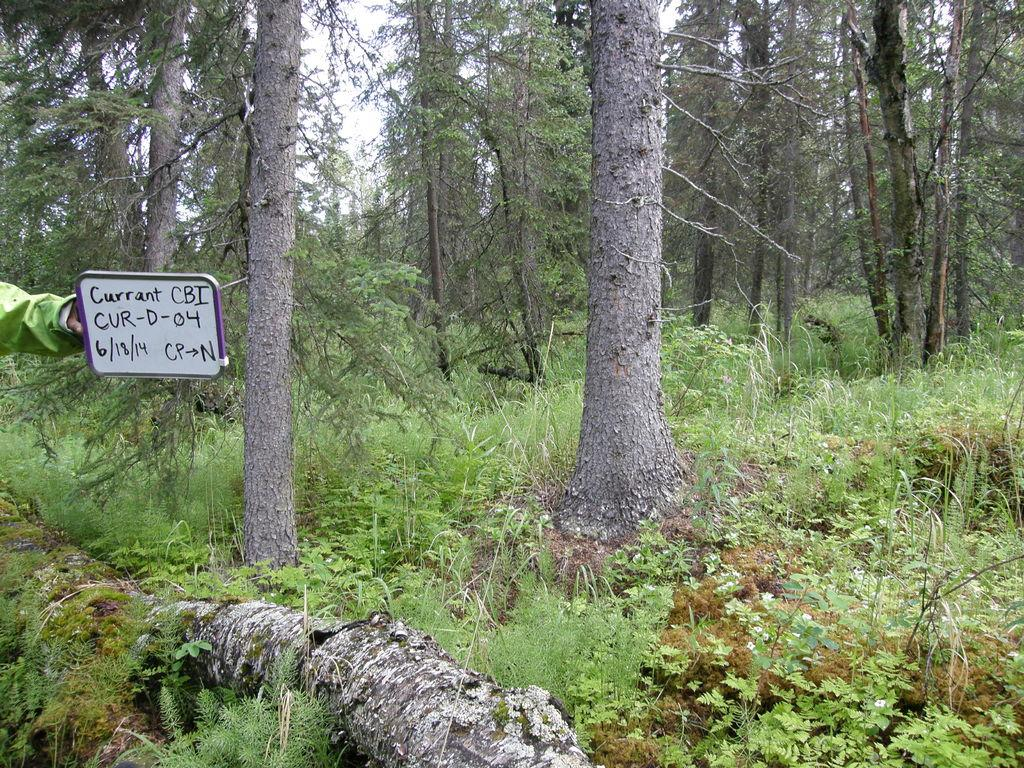What type of environment is depicted in the image? The image is taken in a forest. What can be seen in abundance in the forest? There are many trees in the image. Where is the person holding a text board located in the image? The person holding a text board is on the left side of the image. How many beads are hanging from the trees in the image? There are no beads hanging from the trees in the image; it is a forest with trees and a person holding a text board. What type of snakes can be seen slithering through the forest in the image? There are no snakes visible in the image; it is a forest with trees and a person holding a text board. 